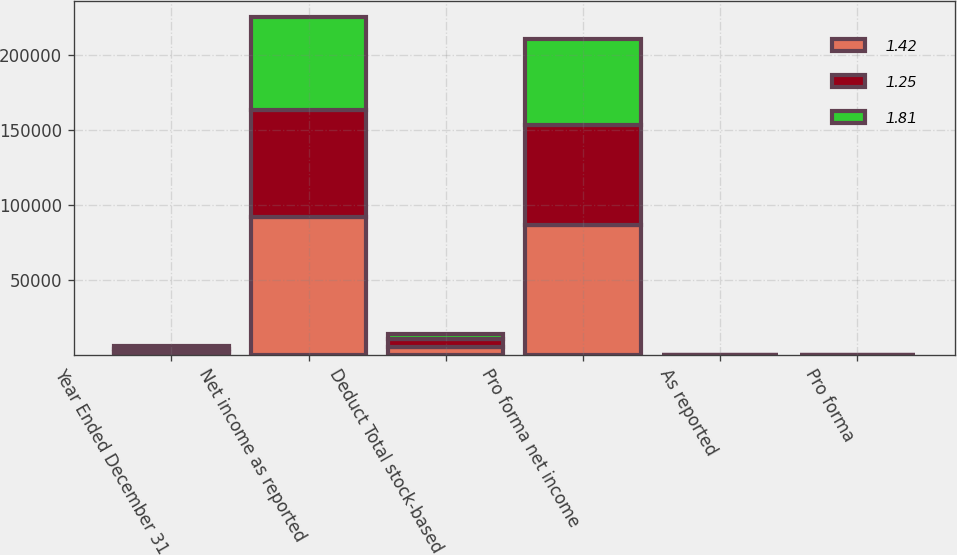Convert chart to OTSL. <chart><loc_0><loc_0><loc_500><loc_500><stacked_bar_chart><ecel><fcel>Year Ended December 31<fcel>Net income as reported<fcel>Deduct Total stock-based<fcel>Pro forma net income<fcel>As reported<fcel>Pro forma<nl><fcel>1.42<fcel>2003<fcel>91696<fcel>5374<fcel>86322<fcel>1.95<fcel>1.83<nl><fcel>1.25<fcel>2002<fcel>71595<fcel>5102<fcel>66493<fcel>1.54<fcel>1.43<nl><fcel>1.81<fcel>2001<fcel>61529<fcel>3558<fcel>57971<fcel>1.34<fcel>1.26<nl></chart> 